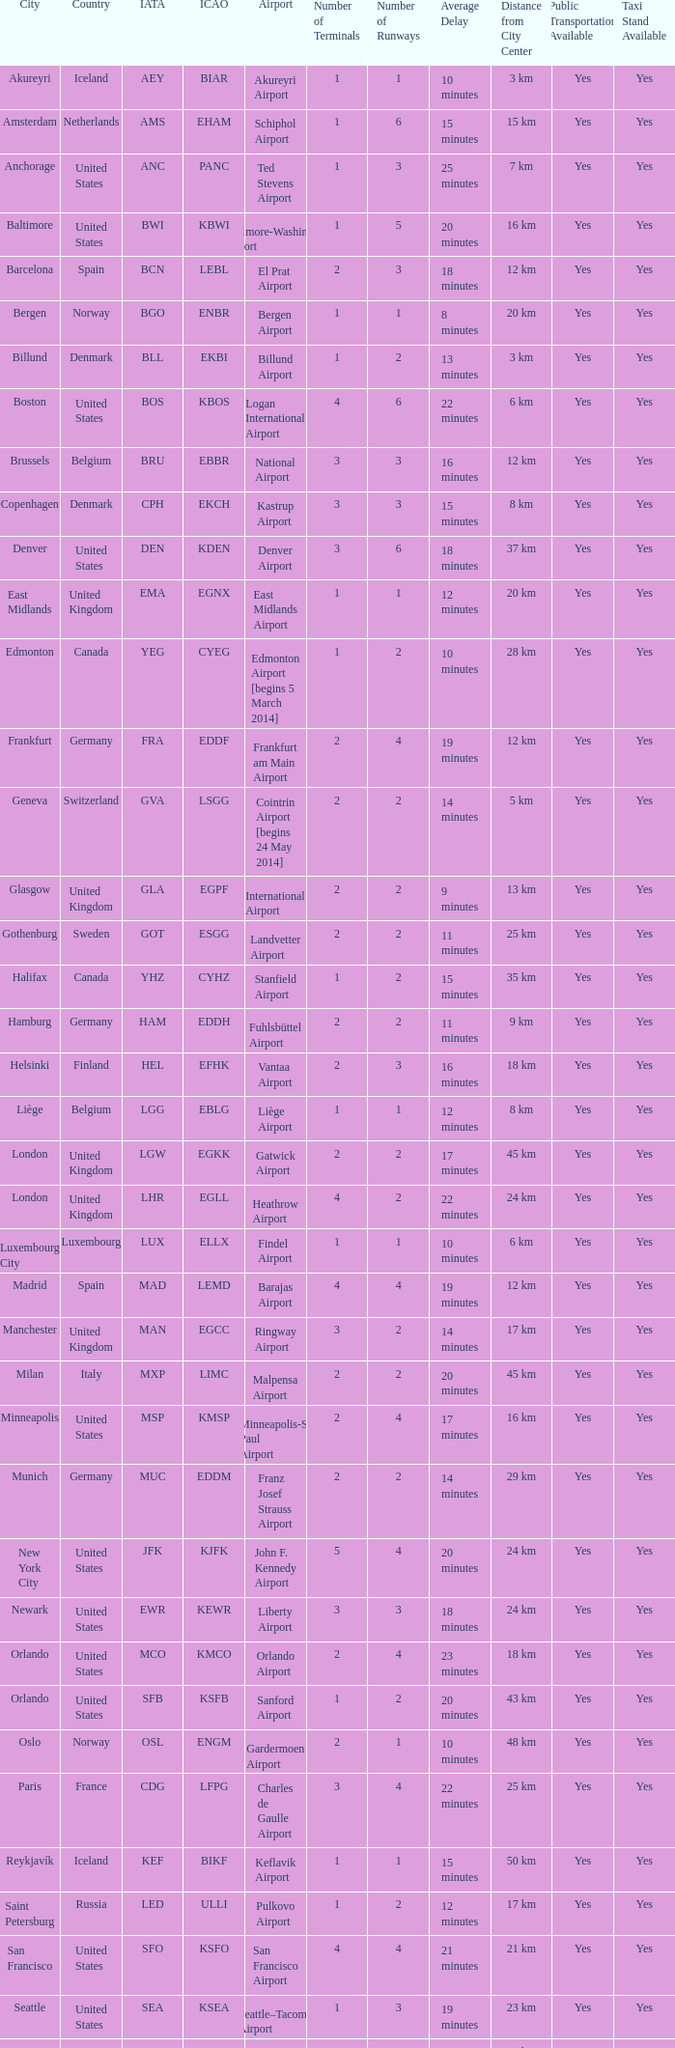What is the Airport with a ICAO of EDDH? Fuhlsbüttel Airport. 